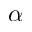Convert formula to latex. <formula><loc_0><loc_0><loc_500><loc_500>\alpha</formula> 